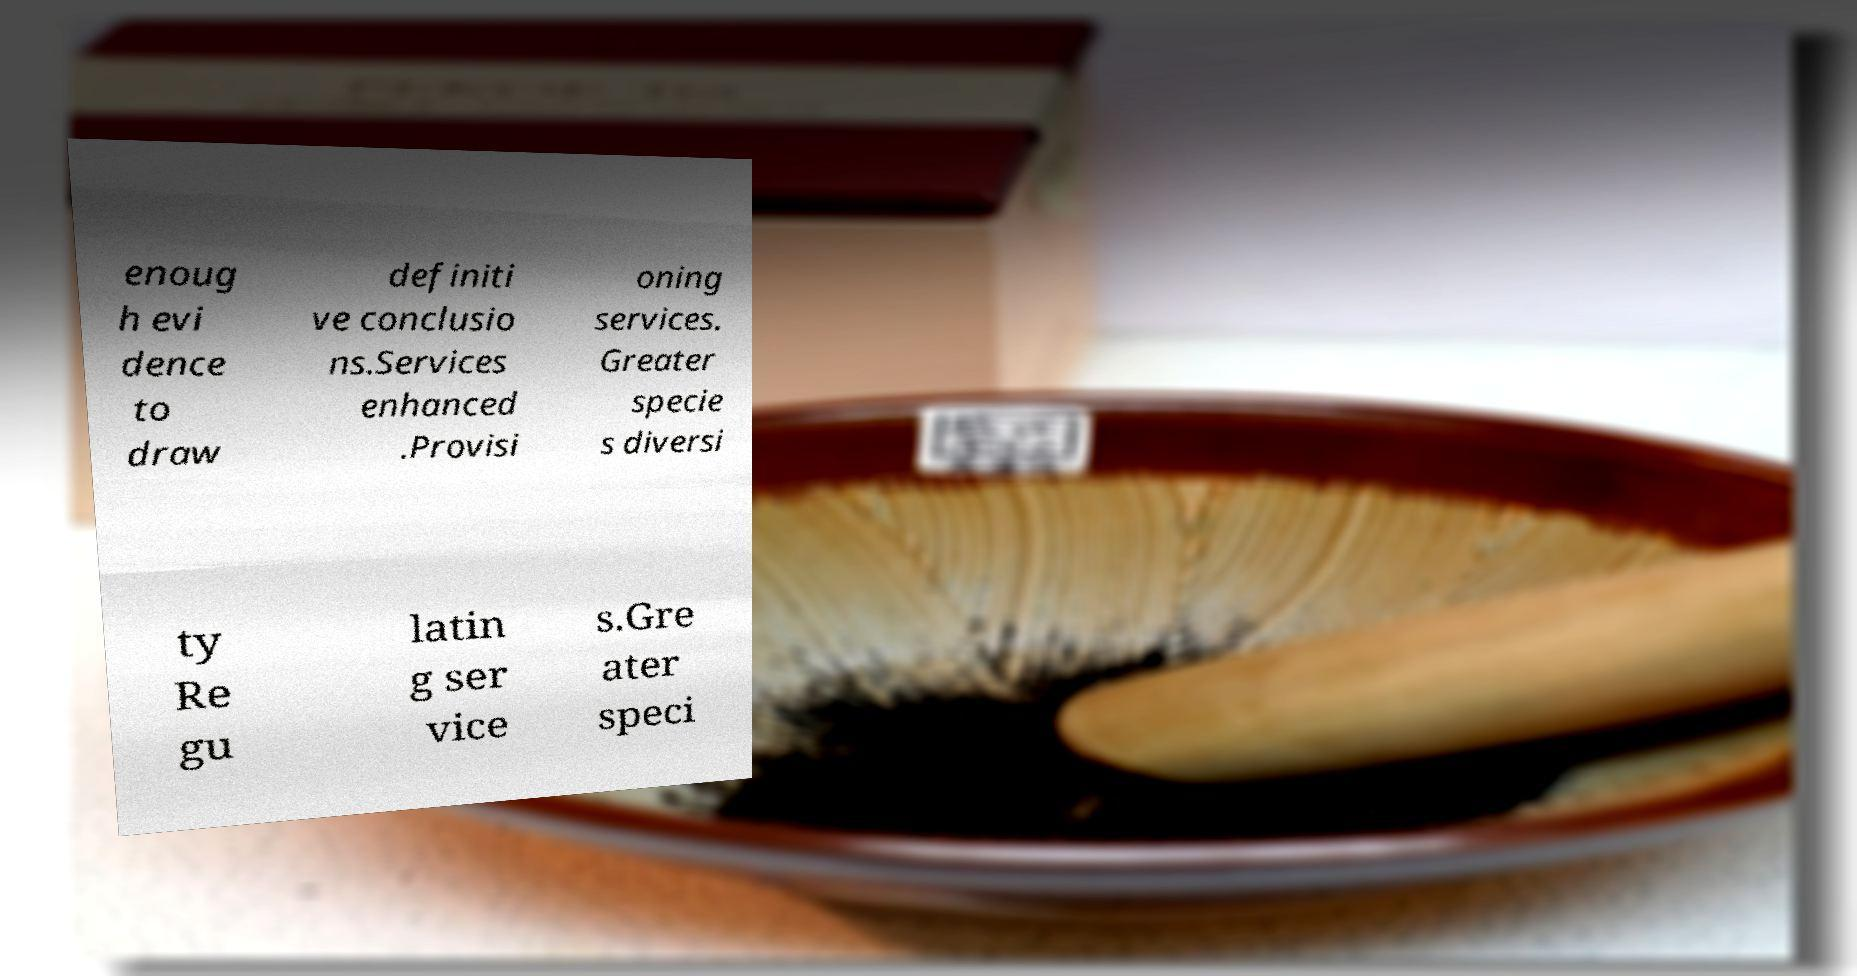I need the written content from this picture converted into text. Can you do that? enoug h evi dence to draw definiti ve conclusio ns.Services enhanced .Provisi oning services. Greater specie s diversi ty Re gu latin g ser vice s.Gre ater speci 